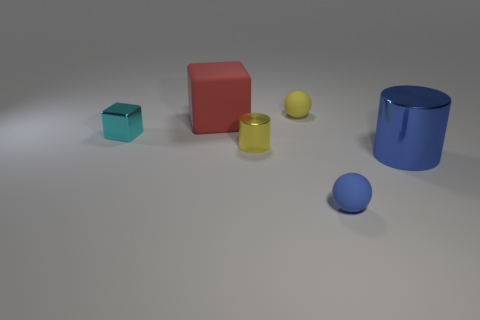What number of other objects are there of the same color as the large rubber object?
Provide a short and direct response. 0. Does the large object that is in front of the yellow metallic thing have the same material as the small yellow cylinder?
Offer a very short reply. Yes. What material is the block that is the same size as the yellow metallic object?
Make the answer very short. Metal. Does the blue cylinder have the same size as the object behind the matte cube?
Ensure brevity in your answer.  No. Are there fewer blue matte objects that are left of the big rubber block than tiny objects behind the yellow metal cylinder?
Your response must be concise. Yes. What size is the yellow object that is in front of the yellow ball?
Provide a succinct answer. Small. Does the red block have the same size as the blue cylinder?
Provide a succinct answer. Yes. How many tiny things are behind the small block and in front of the tiny metallic cylinder?
Your response must be concise. 0. How many purple objects are either metallic cubes or small matte blocks?
Your response must be concise. 0. How many matte things are big purple balls or big cylinders?
Provide a short and direct response. 0. 